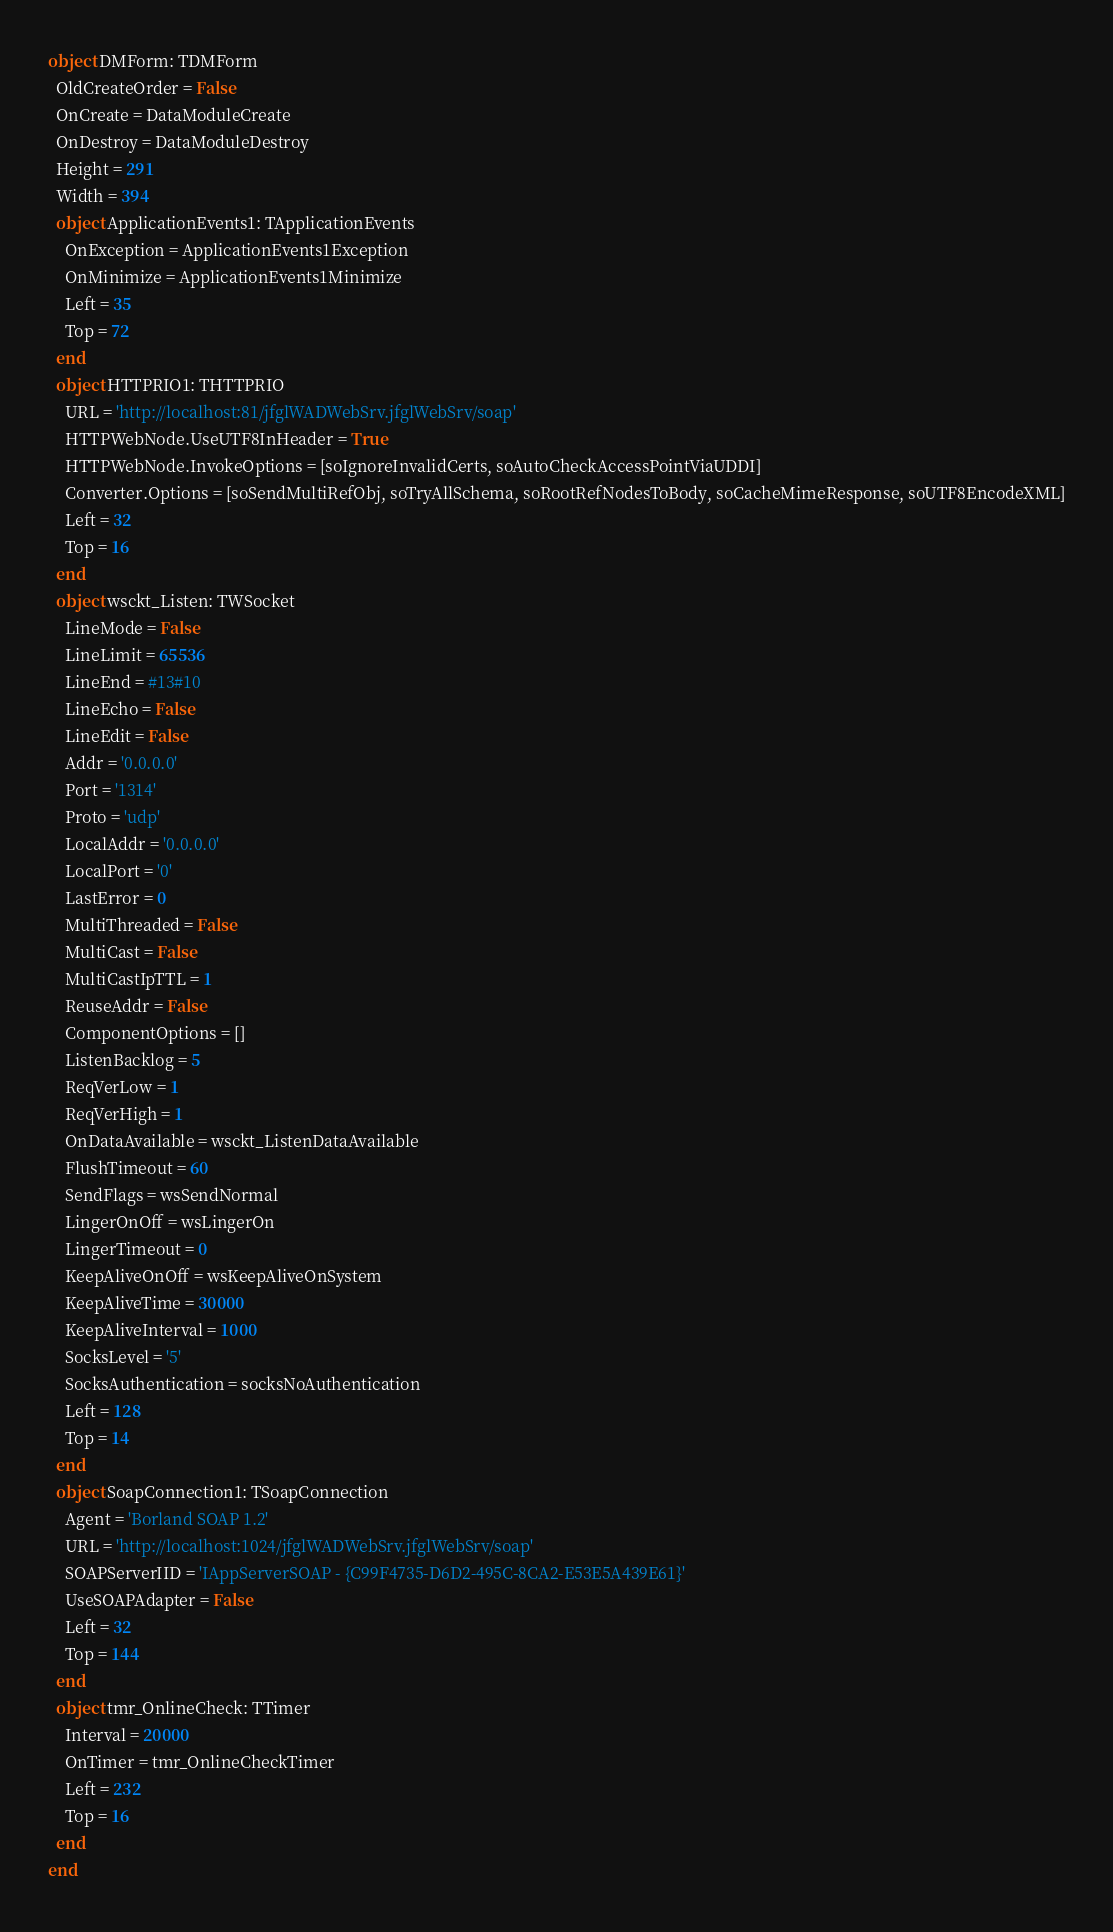<code> <loc_0><loc_0><loc_500><loc_500><_Pascal_>object DMForm: TDMForm
  OldCreateOrder = False
  OnCreate = DataModuleCreate
  OnDestroy = DataModuleDestroy
  Height = 291
  Width = 394
  object ApplicationEvents1: TApplicationEvents
    OnException = ApplicationEvents1Exception
    OnMinimize = ApplicationEvents1Minimize
    Left = 35
    Top = 72
  end
  object HTTPRIO1: THTTPRIO
    URL = 'http://localhost:81/jfglWADWebSrv.jfglWebSrv/soap'
    HTTPWebNode.UseUTF8InHeader = True
    HTTPWebNode.InvokeOptions = [soIgnoreInvalidCerts, soAutoCheckAccessPointViaUDDI]
    Converter.Options = [soSendMultiRefObj, soTryAllSchema, soRootRefNodesToBody, soCacheMimeResponse, soUTF8EncodeXML]
    Left = 32
    Top = 16
  end
  object wsckt_Listen: TWSocket
    LineMode = False
    LineLimit = 65536
    LineEnd = #13#10
    LineEcho = False
    LineEdit = False
    Addr = '0.0.0.0'
    Port = '1314'
    Proto = 'udp'
    LocalAddr = '0.0.0.0'
    LocalPort = '0'
    LastError = 0
    MultiThreaded = False
    MultiCast = False
    MultiCastIpTTL = 1
    ReuseAddr = False
    ComponentOptions = []
    ListenBacklog = 5
    ReqVerLow = 1
    ReqVerHigh = 1
    OnDataAvailable = wsckt_ListenDataAvailable
    FlushTimeout = 60
    SendFlags = wsSendNormal
    LingerOnOff = wsLingerOn
    LingerTimeout = 0
    KeepAliveOnOff = wsKeepAliveOnSystem
    KeepAliveTime = 30000
    KeepAliveInterval = 1000
    SocksLevel = '5'
    SocksAuthentication = socksNoAuthentication
    Left = 128
    Top = 14
  end
  object SoapConnection1: TSoapConnection
    Agent = 'Borland SOAP 1.2'
    URL = 'http://localhost:1024/jfglWADWebSrv.jfglWebSrv/soap'
    SOAPServerIID = 'IAppServerSOAP - {C99F4735-D6D2-495C-8CA2-E53E5A439E61}'
    UseSOAPAdapter = False
    Left = 32
    Top = 144
  end
  object tmr_OnlineCheck: TTimer
    Interval = 20000
    OnTimer = tmr_OnlineCheckTimer
    Left = 232
    Top = 16
  end
end
</code> 